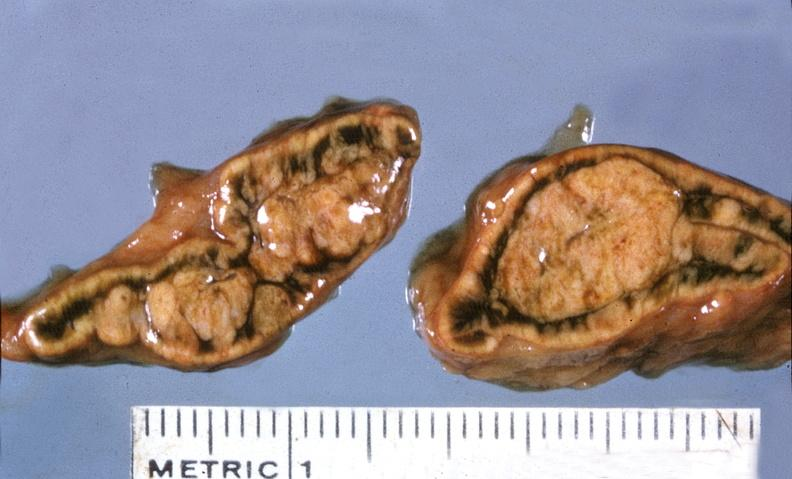does this image show adrenal, cortical adenoma?
Answer the question using a single word or phrase. Yes 